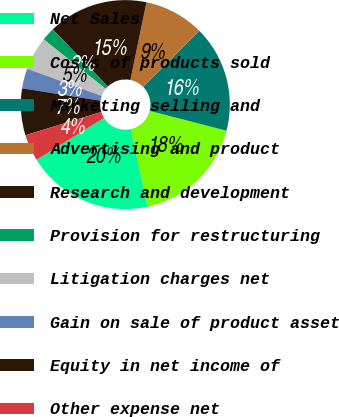Convert chart to OTSL. <chart><loc_0><loc_0><loc_500><loc_500><pie_chart><fcel>Net Sales<fcel>Costs of products sold<fcel>Marketing selling and<fcel>Advertising and product<fcel>Research and development<fcel>Provision for restructuring<fcel>Litigation charges net<fcel>Gain on sale of product asset<fcel>Equity in net income of<fcel>Other expense net<nl><fcel>19.59%<fcel>17.53%<fcel>16.49%<fcel>9.28%<fcel>15.46%<fcel>2.06%<fcel>5.15%<fcel>3.09%<fcel>7.22%<fcel>4.12%<nl></chart> 